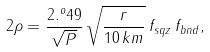Convert formula to latex. <formula><loc_0><loc_0><loc_500><loc_500>2 \rho = \frac { 2 . ^ { o } 4 9 } { \sqrt { P } } \, \sqrt { \frac { r } { 1 0 \, k m } } \, f _ { s q z } \, f _ { b n d } ,</formula> 